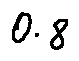Convert formula to latex. <formula><loc_0><loc_0><loc_500><loc_500>0 . 8</formula> 